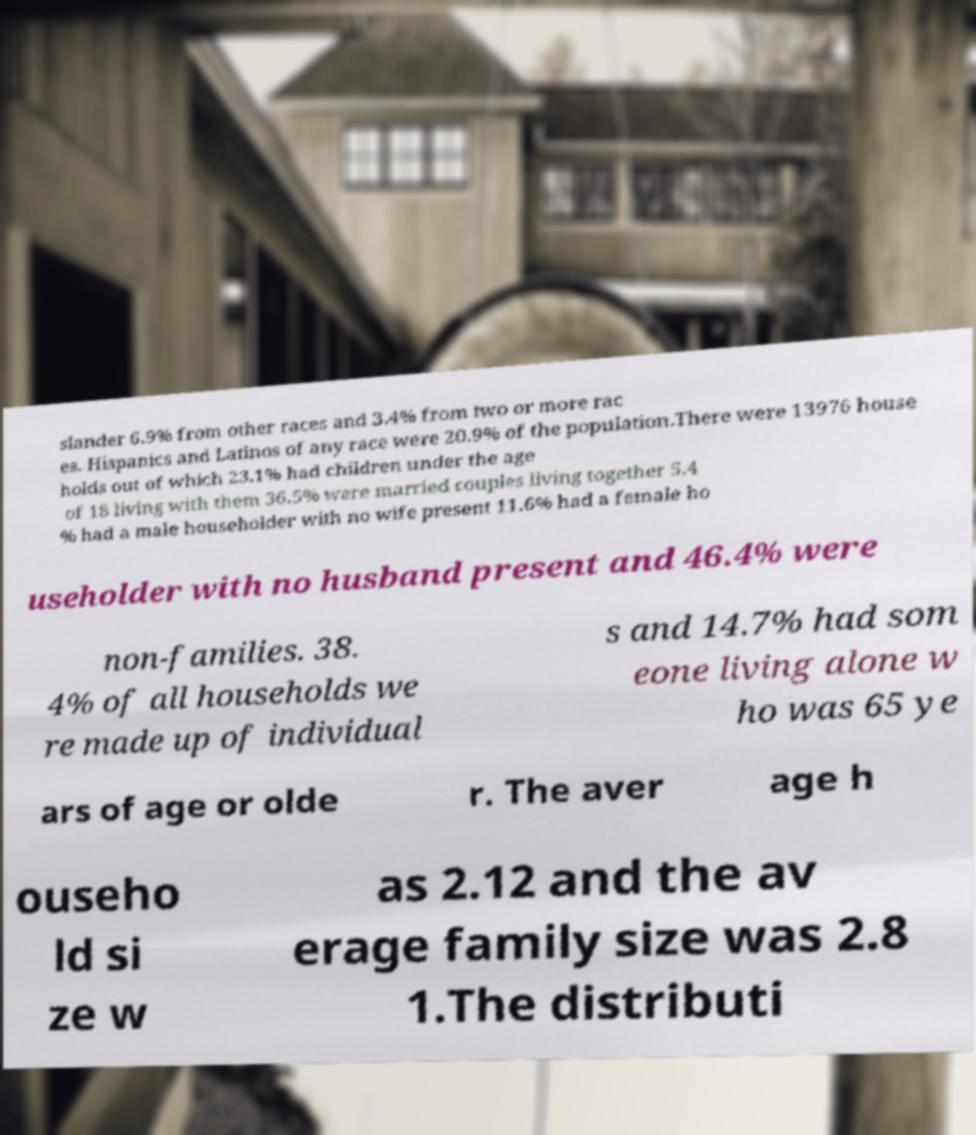Please identify and transcribe the text found in this image. slander 6.9% from other races and 3.4% from two or more rac es. Hispanics and Latinos of any race were 20.9% of the population.There were 13976 house holds out of which 23.1% had children under the age of 18 living with them 36.5% were married couples living together 5.4 % had a male householder with no wife present 11.6% had a female ho useholder with no husband present and 46.4% were non-families. 38. 4% of all households we re made up of individual s and 14.7% had som eone living alone w ho was 65 ye ars of age or olde r. The aver age h ouseho ld si ze w as 2.12 and the av erage family size was 2.8 1.The distributi 